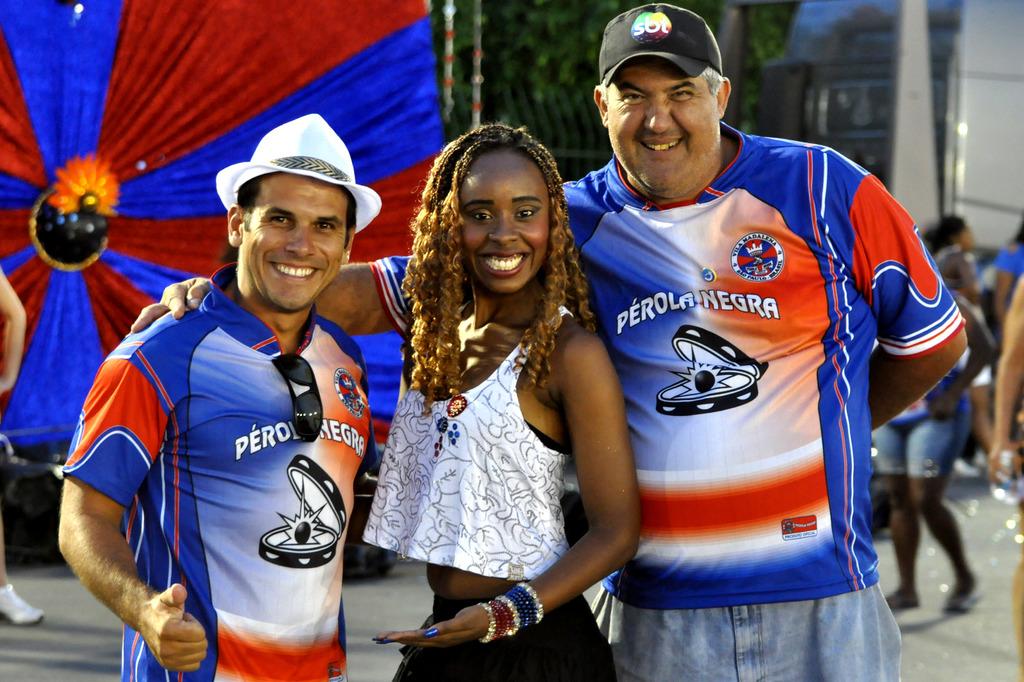What is the name of their team?
Offer a terse response. Perola negra. What letters are seen on the black baseball cap?
Make the answer very short. Sbt. 